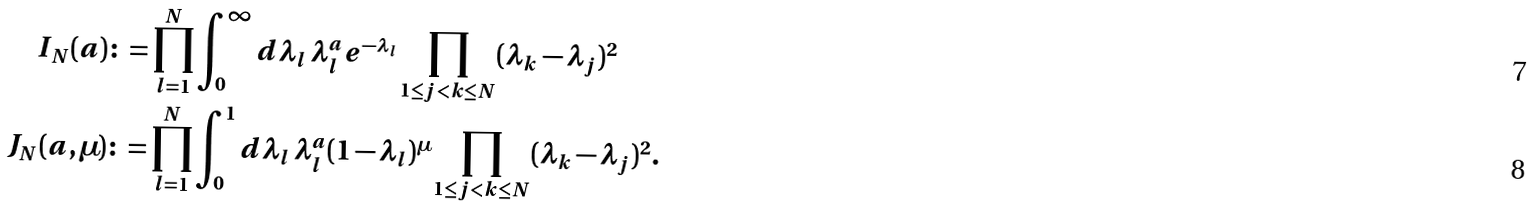<formula> <loc_0><loc_0><loc_500><loc_500>I _ { N } ( a ) & \colon = \prod ^ { N } _ { l = 1 } \int _ { 0 } ^ { \infty } d \lambda _ { l } \, \lambda _ { l } ^ { a } e ^ { - \lambda _ { l } } \prod _ { 1 \leq j < k \leq N } ( \lambda _ { k } - \lambda _ { j } ) ^ { 2 } \\ J _ { N } ( a , \mu ) & \colon = \prod ^ { N } _ { l = 1 } \int _ { 0 } ^ { 1 } d \lambda _ { l } \, \lambda _ { l } ^ { a } ( 1 - \lambda _ { l } ) ^ { \mu } \prod _ { 1 \leq j < k \leq N } ( \lambda _ { k } - \lambda _ { j } ) ^ { 2 } .</formula> 